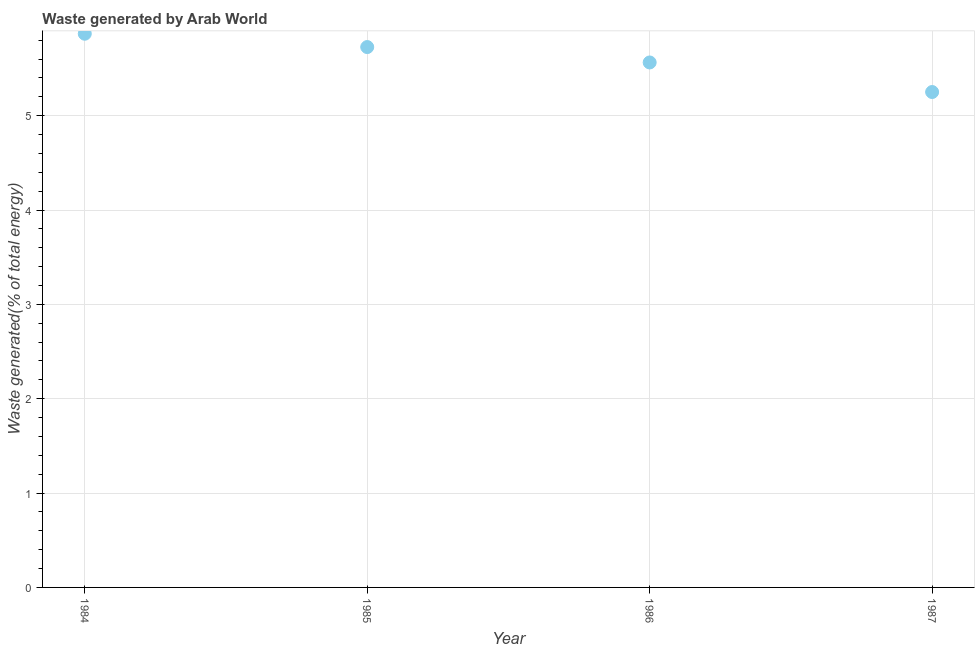What is the amount of waste generated in 1984?
Ensure brevity in your answer.  5.87. Across all years, what is the maximum amount of waste generated?
Make the answer very short. 5.87. Across all years, what is the minimum amount of waste generated?
Keep it short and to the point. 5.25. In which year was the amount of waste generated maximum?
Ensure brevity in your answer.  1984. What is the sum of the amount of waste generated?
Provide a succinct answer. 22.41. What is the difference between the amount of waste generated in 1984 and 1987?
Provide a short and direct response. 0.62. What is the average amount of waste generated per year?
Provide a short and direct response. 5.6. What is the median amount of waste generated?
Your response must be concise. 5.65. In how many years, is the amount of waste generated greater than 4.6 %?
Your response must be concise. 4. What is the ratio of the amount of waste generated in 1984 to that in 1985?
Ensure brevity in your answer.  1.02. Is the amount of waste generated in 1986 less than that in 1987?
Offer a very short reply. No. Is the difference between the amount of waste generated in 1985 and 1986 greater than the difference between any two years?
Provide a succinct answer. No. What is the difference between the highest and the second highest amount of waste generated?
Give a very brief answer. 0.14. What is the difference between the highest and the lowest amount of waste generated?
Your response must be concise. 0.62. In how many years, is the amount of waste generated greater than the average amount of waste generated taken over all years?
Keep it short and to the point. 2. Does the amount of waste generated monotonically increase over the years?
Offer a very short reply. No. How many years are there in the graph?
Offer a very short reply. 4. What is the difference between two consecutive major ticks on the Y-axis?
Your response must be concise. 1. Does the graph contain any zero values?
Give a very brief answer. No. What is the title of the graph?
Give a very brief answer. Waste generated by Arab World. What is the label or title of the Y-axis?
Offer a very short reply. Waste generated(% of total energy). What is the Waste generated(% of total energy) in 1984?
Offer a very short reply. 5.87. What is the Waste generated(% of total energy) in 1985?
Your answer should be very brief. 5.73. What is the Waste generated(% of total energy) in 1986?
Provide a succinct answer. 5.56. What is the Waste generated(% of total energy) in 1987?
Offer a terse response. 5.25. What is the difference between the Waste generated(% of total energy) in 1984 and 1985?
Your answer should be very brief. 0.14. What is the difference between the Waste generated(% of total energy) in 1984 and 1986?
Offer a terse response. 0.3. What is the difference between the Waste generated(% of total energy) in 1984 and 1987?
Keep it short and to the point. 0.62. What is the difference between the Waste generated(% of total energy) in 1985 and 1986?
Provide a succinct answer. 0.16. What is the difference between the Waste generated(% of total energy) in 1985 and 1987?
Give a very brief answer. 0.48. What is the difference between the Waste generated(% of total energy) in 1986 and 1987?
Offer a very short reply. 0.31. What is the ratio of the Waste generated(% of total energy) in 1984 to that in 1986?
Keep it short and to the point. 1.05. What is the ratio of the Waste generated(% of total energy) in 1984 to that in 1987?
Your response must be concise. 1.12. What is the ratio of the Waste generated(% of total energy) in 1985 to that in 1987?
Offer a terse response. 1.09. What is the ratio of the Waste generated(% of total energy) in 1986 to that in 1987?
Your response must be concise. 1.06. 